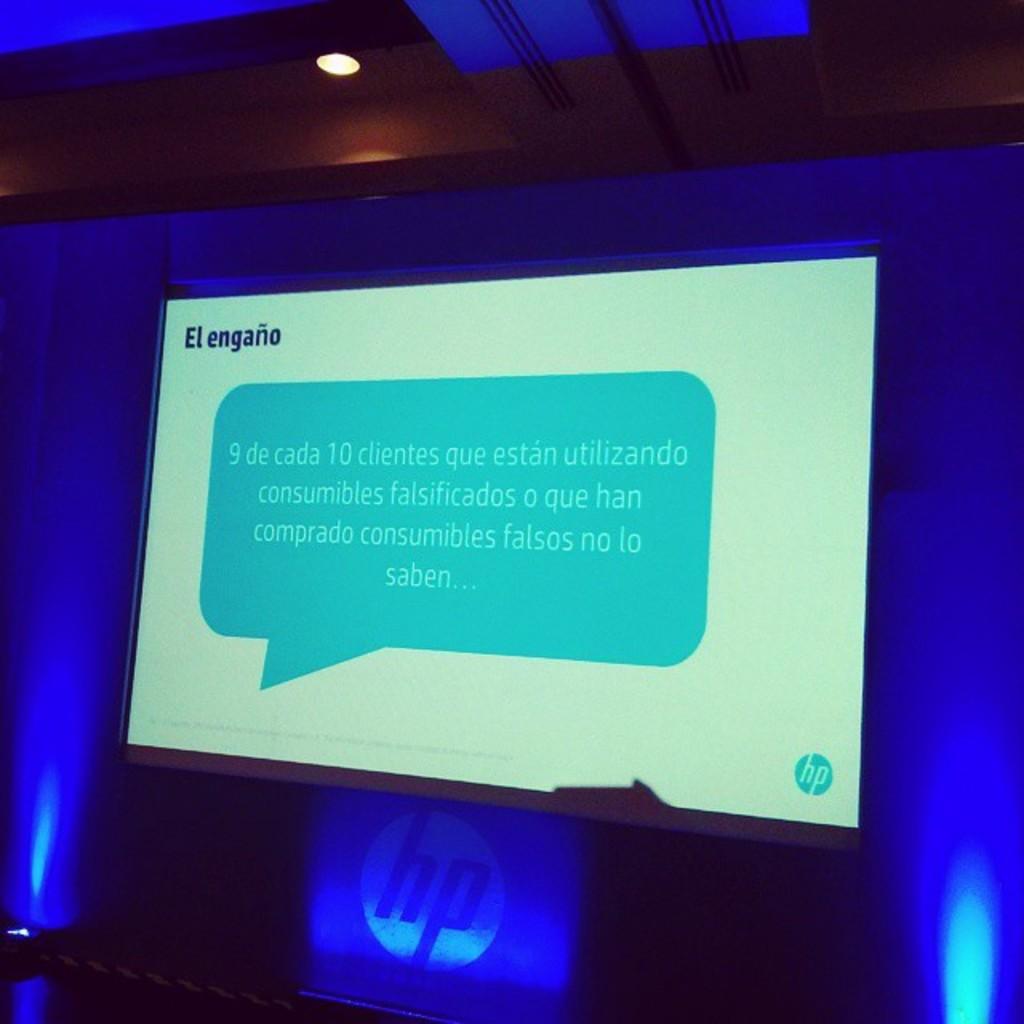What company is giving this presentation?
Make the answer very short. Hp. What is the top left spanish phrase?
Offer a very short reply. El engano. 